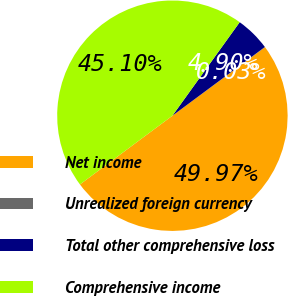Convert chart. <chart><loc_0><loc_0><loc_500><loc_500><pie_chart><fcel>Net income<fcel>Unrealized foreign currency<fcel>Total other comprehensive loss<fcel>Comprehensive income<nl><fcel>49.97%<fcel>0.03%<fcel>4.9%<fcel>45.1%<nl></chart> 